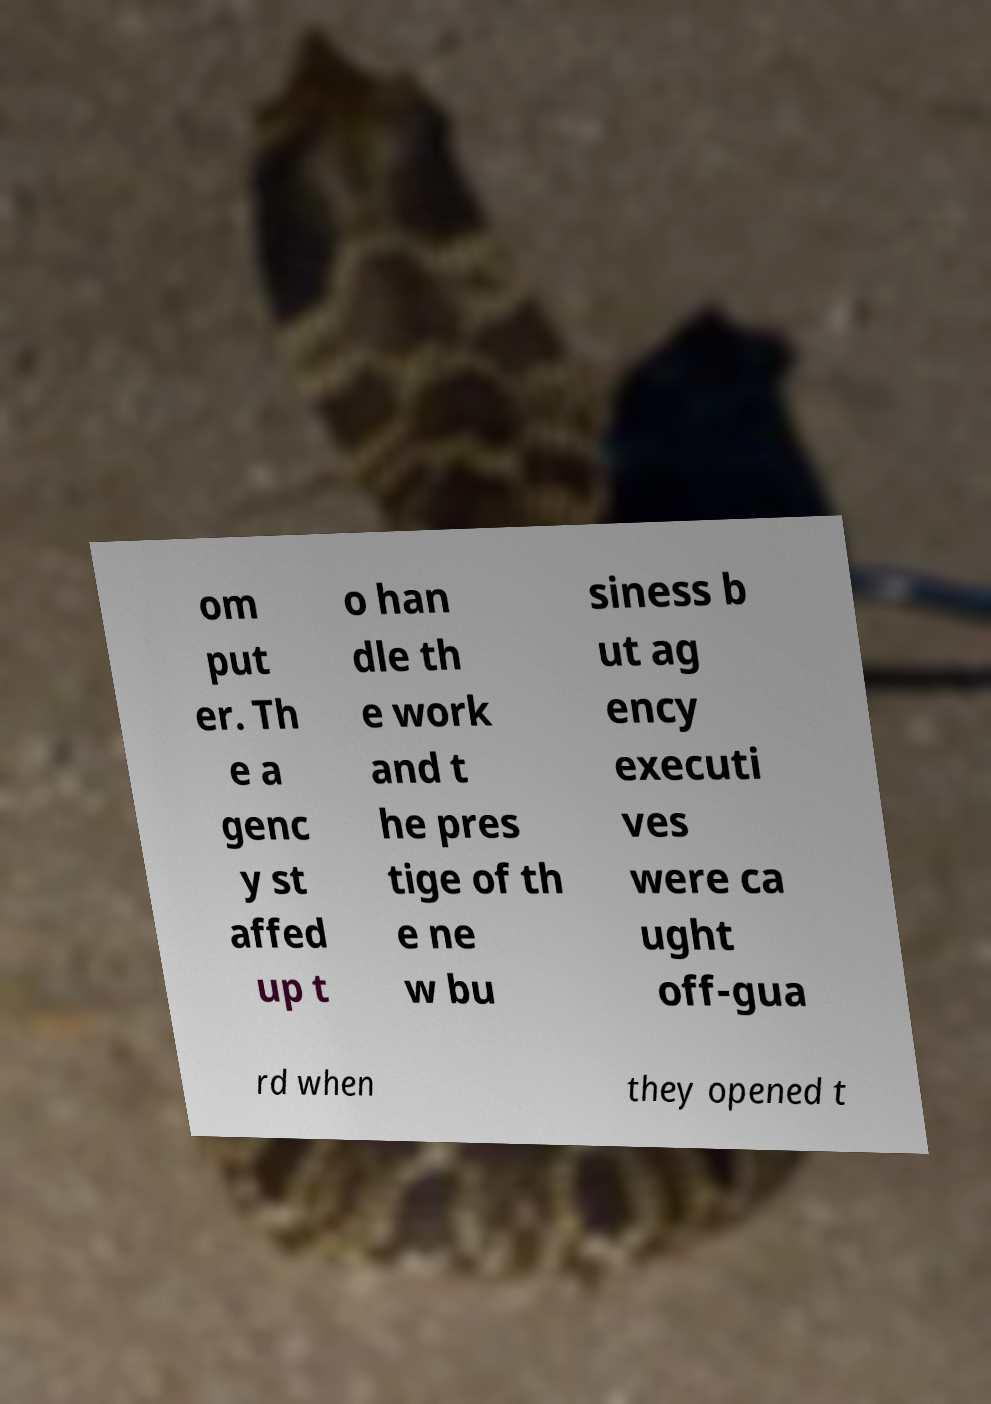Can you read and provide the text displayed in the image?This photo seems to have some interesting text. Can you extract and type it out for me? om put er. Th e a genc y st affed up t o han dle th e work and t he pres tige of th e ne w bu siness b ut ag ency executi ves were ca ught off-gua rd when they opened t 